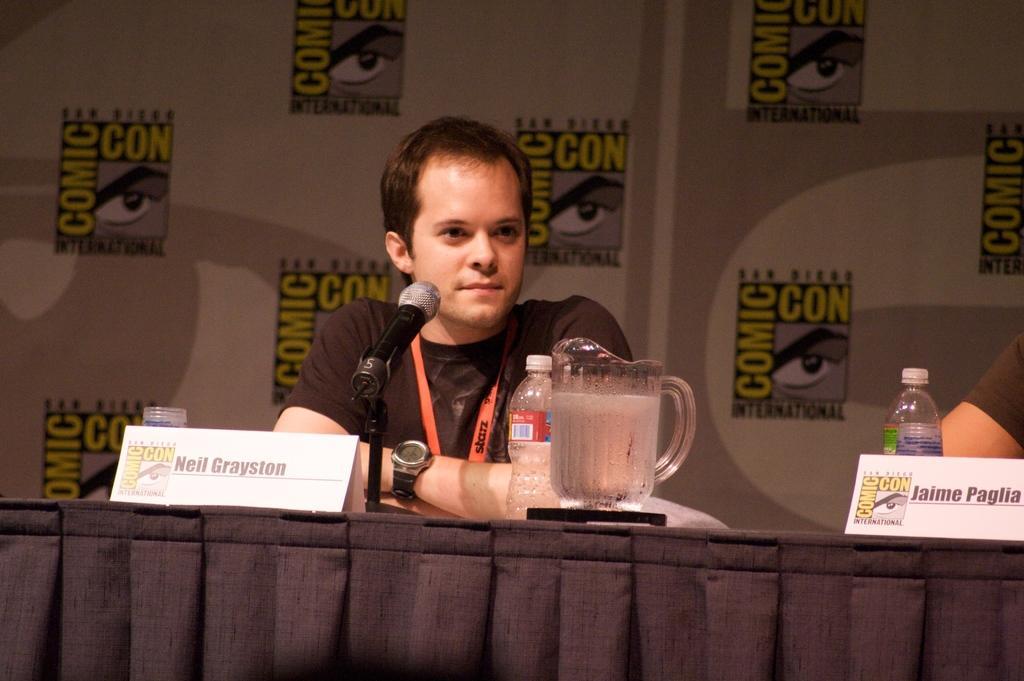In one or two sentences, can you explain what this image depicts? The picture consists of one man in the centre wearing a brown t-shirt and id card and in front of him one table where water bottle, glass jar, name board and microphone are present and behind him there is a poster on which comic icon symbols are present and at the right corner another person is present. 